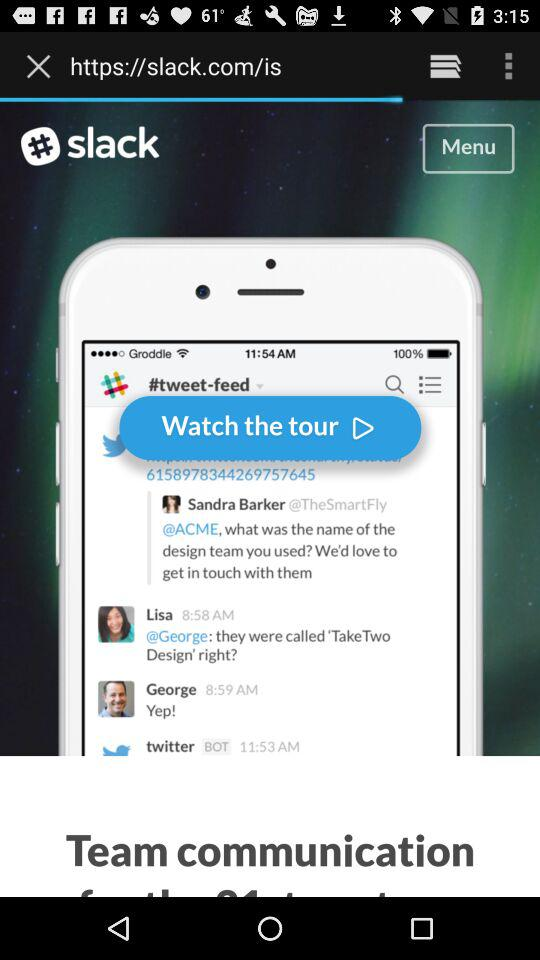What is the name of the application? The name of the application is "slack". 